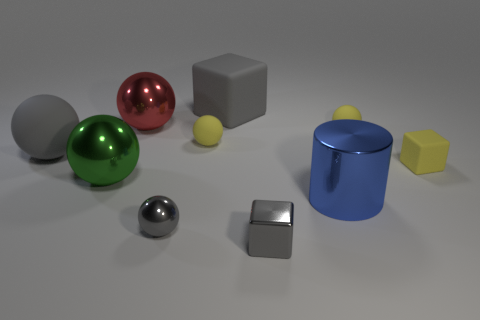Subtract all yellow balls. How many balls are left? 4 Subtract all tiny yellow matte balls. How many balls are left? 4 Subtract all cyan spheres. Subtract all cyan cubes. How many spheres are left? 6 Subtract all cubes. How many objects are left? 7 Add 4 large green metallic objects. How many large green metallic objects exist? 5 Subtract 0 blue balls. How many objects are left? 10 Subtract all big rubber balls. Subtract all large gray things. How many objects are left? 7 Add 6 big gray matte cubes. How many big gray matte cubes are left? 7 